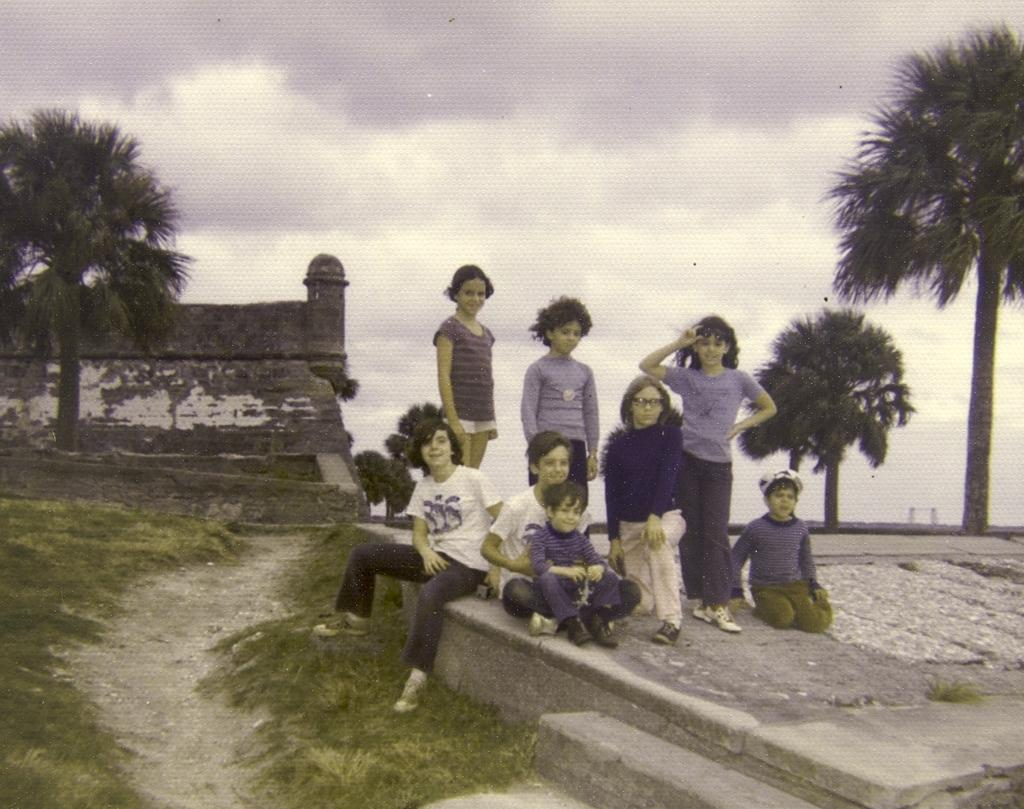How many people are in the image? There is a group of people in the image, but the exact number is not specified. What are the people in the image doing? Some people are sitting, while others are standing. What can be seen in the background of the image? There are trees and a building visible in the background. What is the condition of the sky in the image? Clouds are present in the sky. What type of loaf is being used as a seat by one of the people in the image? There is no loaf present in the image; people are sitting on chairs or standing. What year is depicted in the image? The image does not depict a specific year; it is a snapshot of a moment in time. 